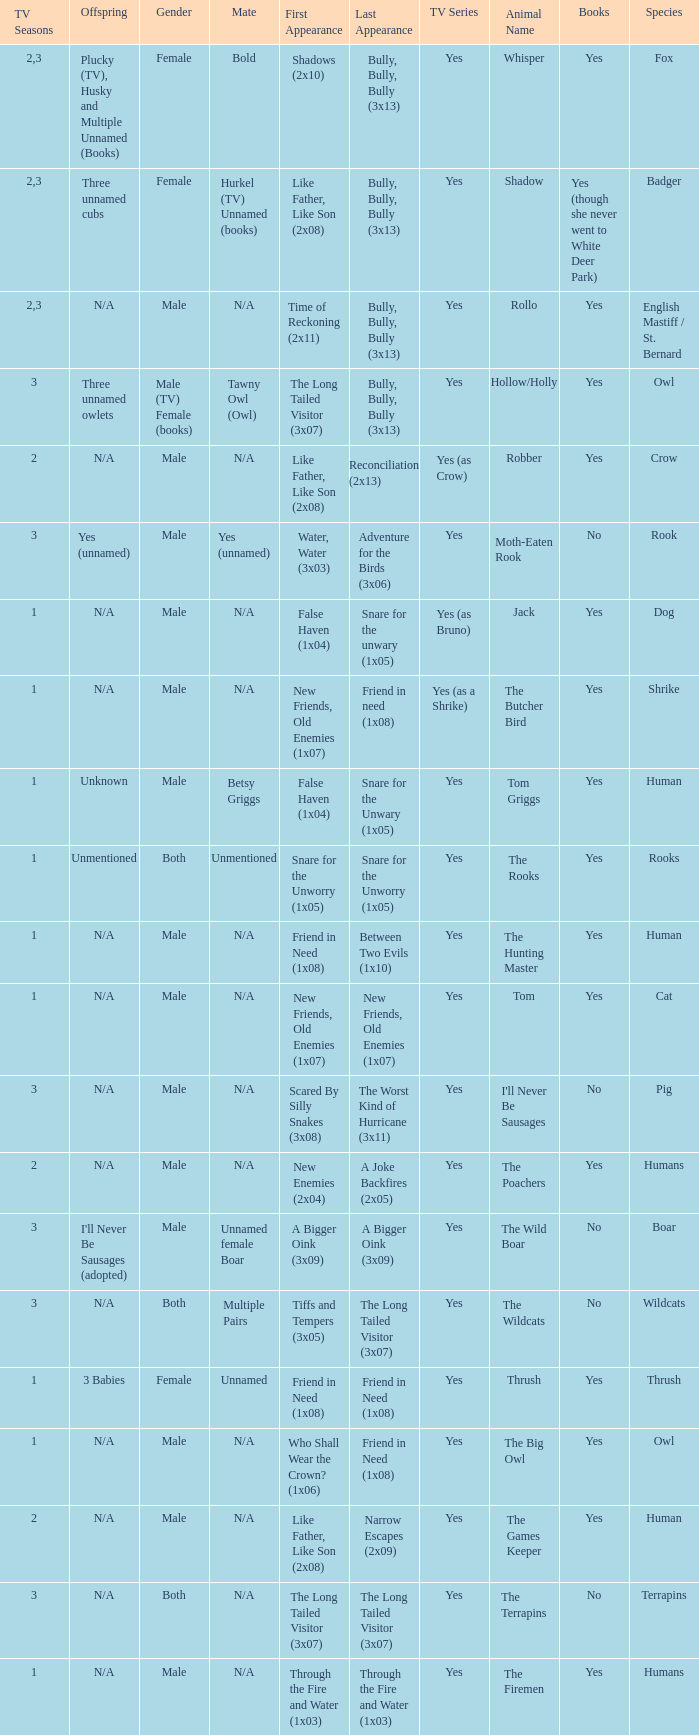What is the smallest season for a tv series with a yes and human was the species? 1.0. 